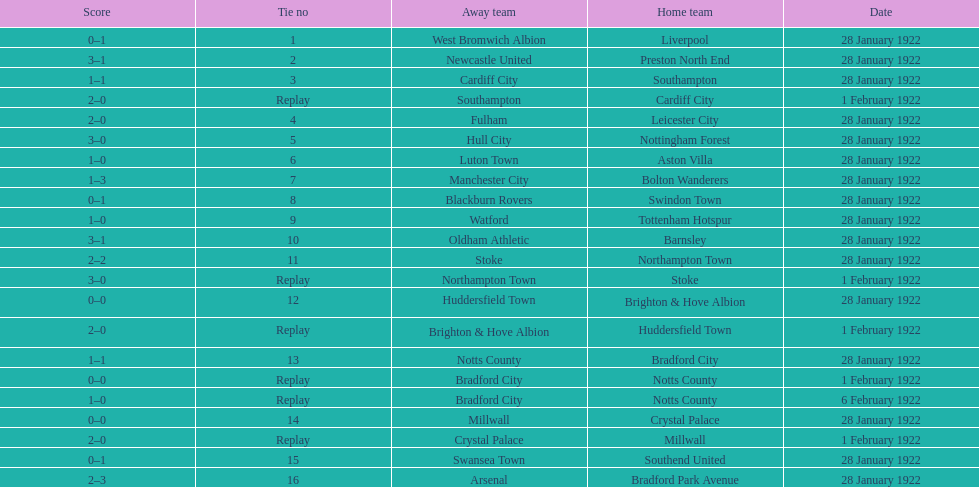How many games had no points scored? 3. 